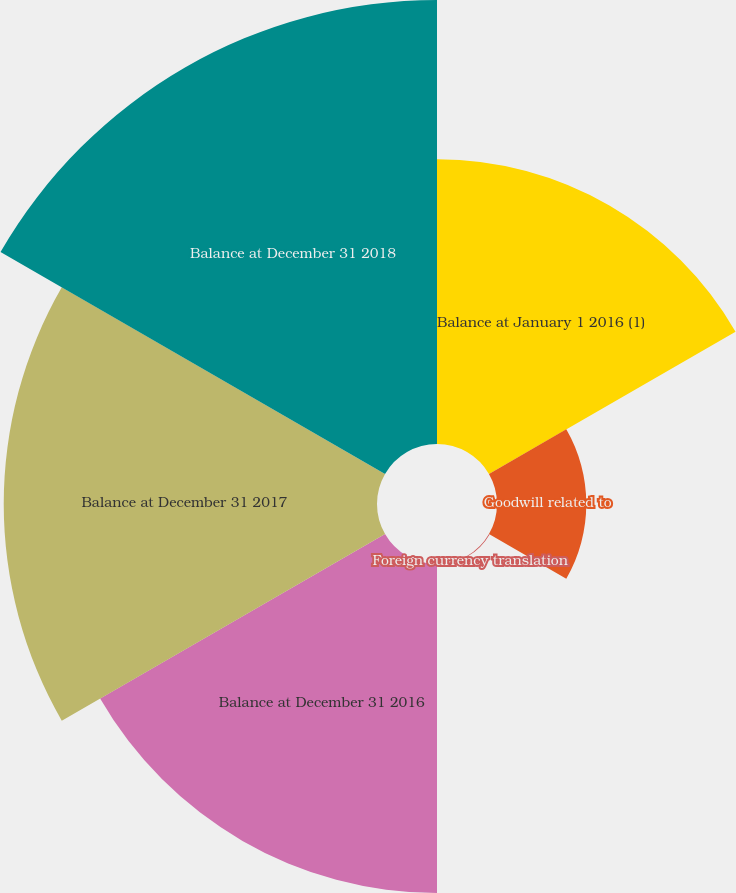Convert chart to OTSL. <chart><loc_0><loc_0><loc_500><loc_500><pie_chart><fcel>Balance at January 1 2016 (1)<fcel>Goodwill related to<fcel>Foreign currency translation<fcel>Balance at December 31 2016<fcel>Balance at December 31 2017<fcel>Balance at December 31 2018<nl><fcel>18.72%<fcel>5.87%<fcel>0.05%<fcel>21.63%<fcel>24.54%<fcel>29.19%<nl></chart> 